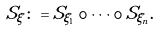Convert formula to latex. <formula><loc_0><loc_0><loc_500><loc_500>S _ { \xi } \colon = S _ { \xi _ { 1 } } \circ \cdots \circ S _ { \xi _ { n } } .</formula> 